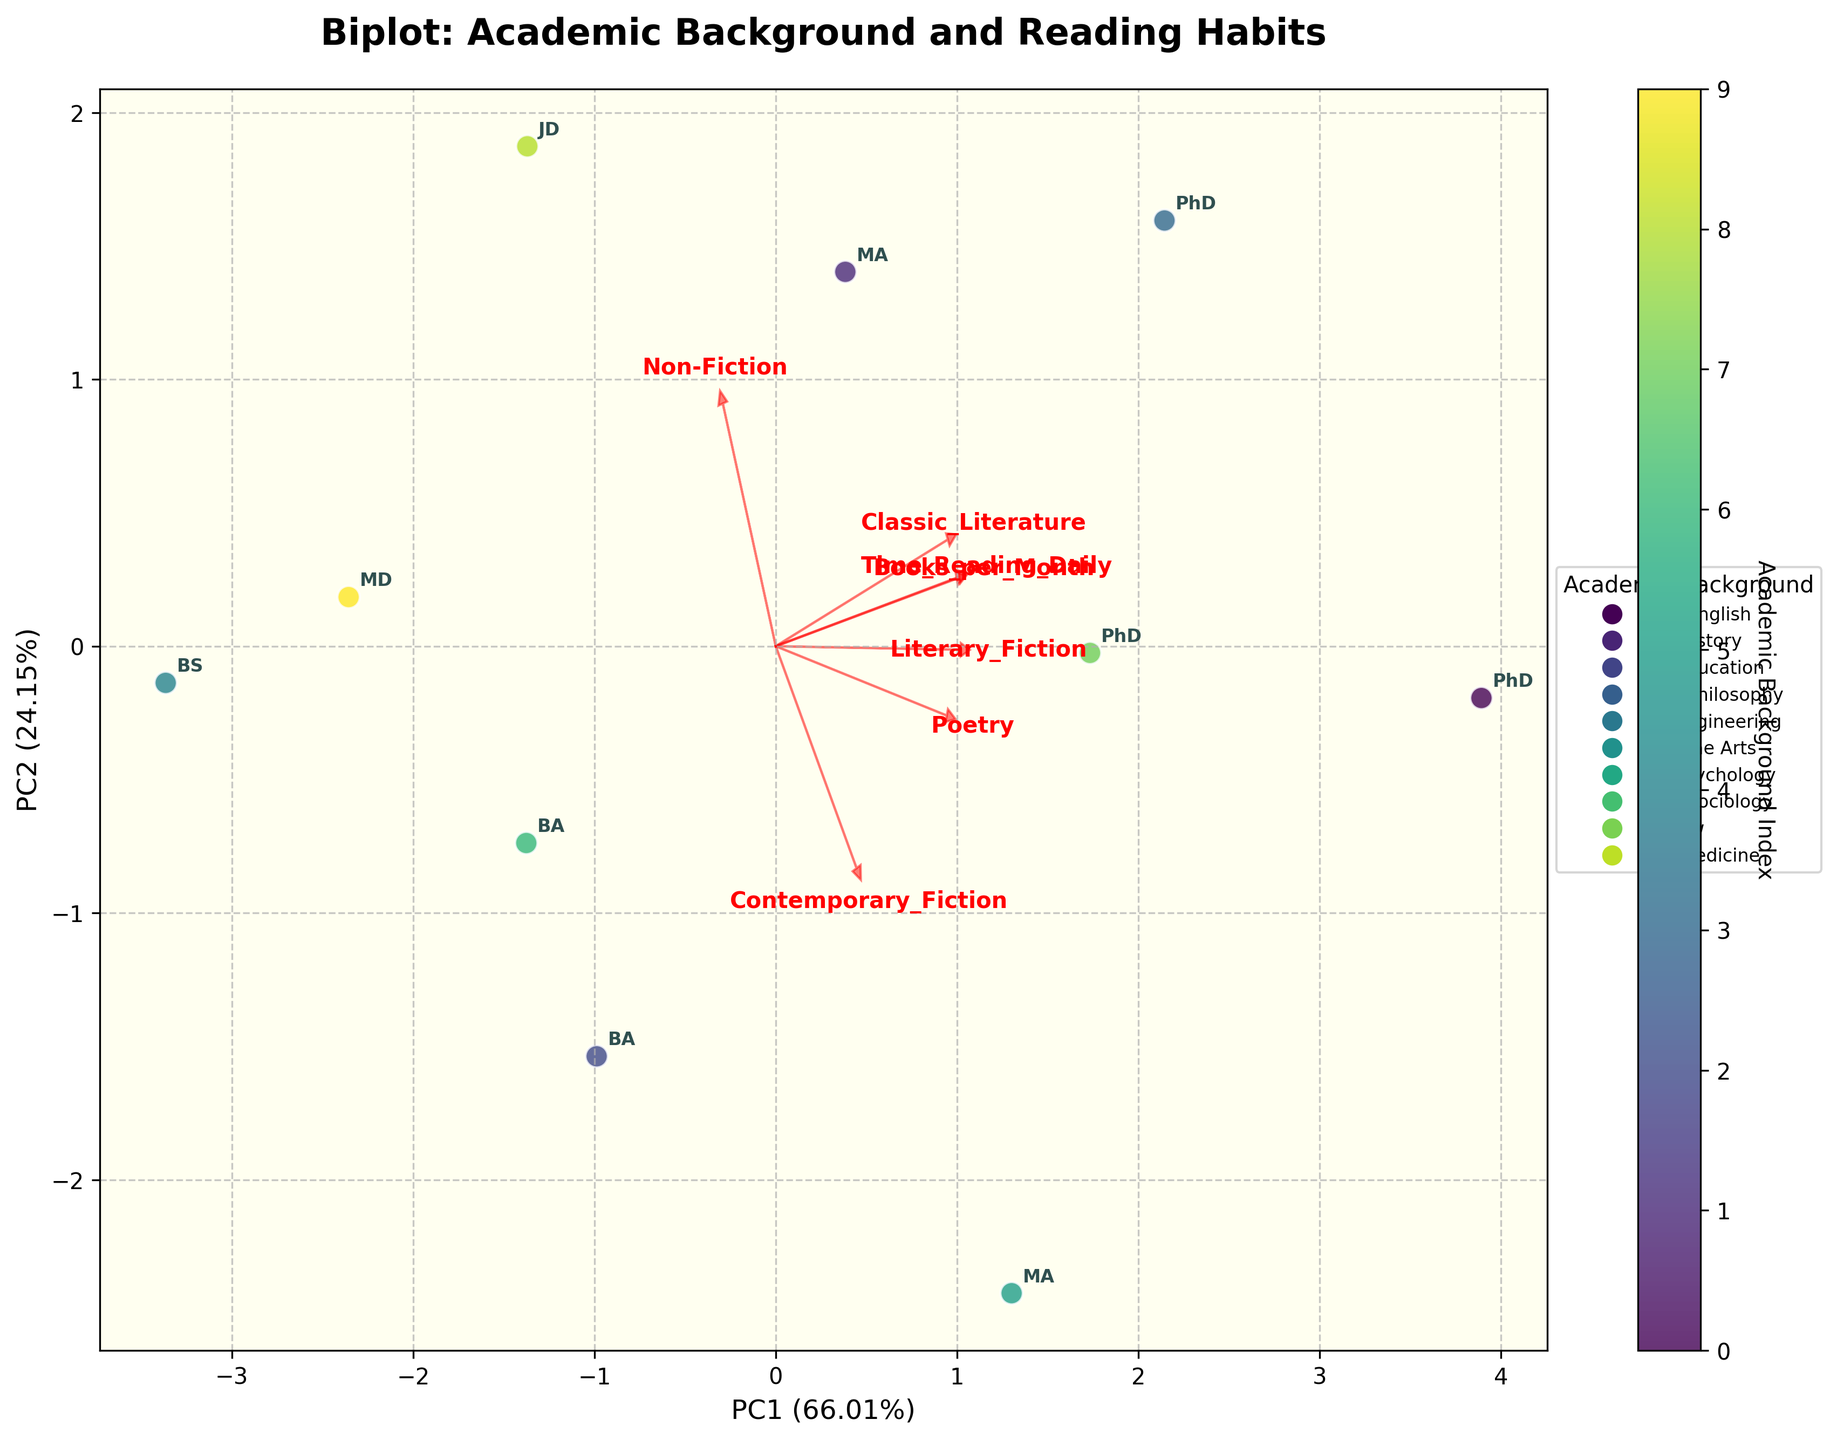What is the title of the plot? The title of the plot is printed at the top and states the main purpose of the visualization. It helps viewers understand what the data and analysis are about.
Answer: Biplot: Academic Background and Reading Habits How many different academic backgrounds are represented in the biplot? By counting the unique labels (the academic backgrounds) annotated around the scatter plot points, we can determine the number of distinct academic backgrounds.
Answer: 10 Which academic background reads the most books per month on average? By observing the direction and length of the arrow labeled "Books_per_Month," we identify the academic background that lies furthest in this direction.
Answer: PhD English What percentage of variance is covered by the first principal component (PC1)? The percentage of variance covered by PC1 is provided in the x-axis label of the biplot. It shows how much of the variation in the data is captured by the first component.
Answer: 42.57% Which genre has the highest loading on PC2? By identifying the vector (arrow) that extends furthest in the y-axis direction (PC2) and reading its label, we can determine which genre has the highest loading on PC2.
Answer: Time_Reading_Daily How does PhD Sociology compare to JD Law in terms of time spent reading daily? Check the position of the points labeled with these academic backgrounds along the PC2 (y-axis) dimension to see which one is higher.
Answer: PhD Sociology spends more time Which two academic backgrounds are closest to each other in the biplot? By examining the Euclidean distance between points labeled with different academic backgrounds in the scatter plot, we can find the closest pair.
Answer: BA Psychology and BA Education If someone reads a lot of poetry, which academic background are they most likely to have? Look at the direction and length of the "Poetry" arrow and find the academic background point(s) furthest along this direction.
Answer: PhD English Is musical preference (e.g., Fine Arts) strongly correlated with reading non-fiction books? By observing the arrow labeled "Non-Fiction" and locating the position of the point labeled "MA Fine_Arts" along this arrow, we can infer if there is a strong correlation.
Answer: Not Strongly Correlated What is the relationship between reading contemporary fiction and having a background in engineering? Examine the position of the "BS Engineering" point in relation to the direction of the "Contemporary_Fiction" arrow to understand their relationship.
Answer: Negative Relationship 